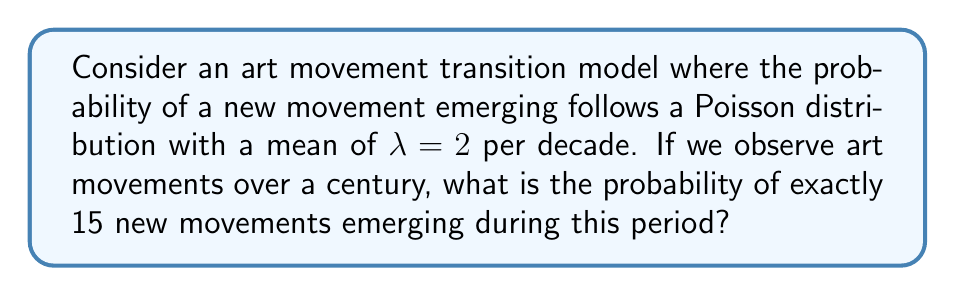Give your solution to this math problem. To solve this problem, we'll use the Poisson distribution formula and apply it to the given scenario. Here's a step-by-step approach:

1. Identify the given information:
   - λ (lambda) = 2 new movements per decade
   - Time period = 1 century = 10 decades
   - k (number of events) = 15 new movements

2. Calculate the adjusted λ for the entire century:
   λ_century = λ * number of decades
   λ_century = 2 * 10 = 20

3. Apply the Poisson distribution formula:
   $$P(X = k) = \frac{e^{-λ} * λ^k}{k!}$$

   Where:
   - e is Euler's number (approximately 2.71828)
   - λ is the average number of events in the interval
   - k is the number of events we're calculating the probability for

4. Substitute the values into the formula:
   $$P(X = 15) = \frac{e^{-20} * 20^{15}}{15!}$$

5. Calculate the result:
   $$P(X = 15) = \frac{2.061153622 * 10^{-9} * 3.2768 * 10^{19}}{1.307674368 * 10^{12}}$$
   $$P(X = 15) ≈ 0.0516$$

6. Convert to a percentage:
   0.0516 * 100 ≈ 5.16%

This means there is approximately a 5.16% chance of exactly 15 new art movements emerging over the course of a century, given the specified model.
Answer: 5.16% 